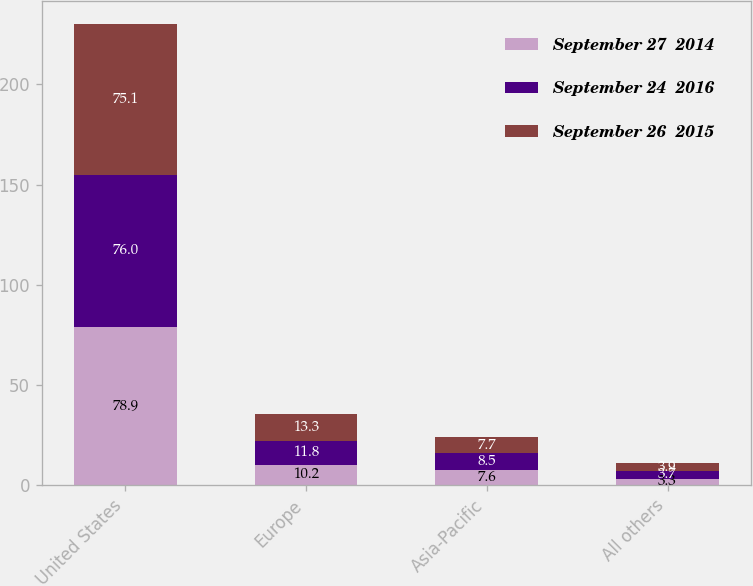Convert chart to OTSL. <chart><loc_0><loc_0><loc_500><loc_500><stacked_bar_chart><ecel><fcel>United States<fcel>Europe<fcel>Asia-Pacific<fcel>All others<nl><fcel>September 27  2014<fcel>78.9<fcel>10.2<fcel>7.6<fcel>3.3<nl><fcel>September 24  2016<fcel>76<fcel>11.8<fcel>8.5<fcel>3.7<nl><fcel>September 26  2015<fcel>75.1<fcel>13.3<fcel>7.7<fcel>3.9<nl></chart> 